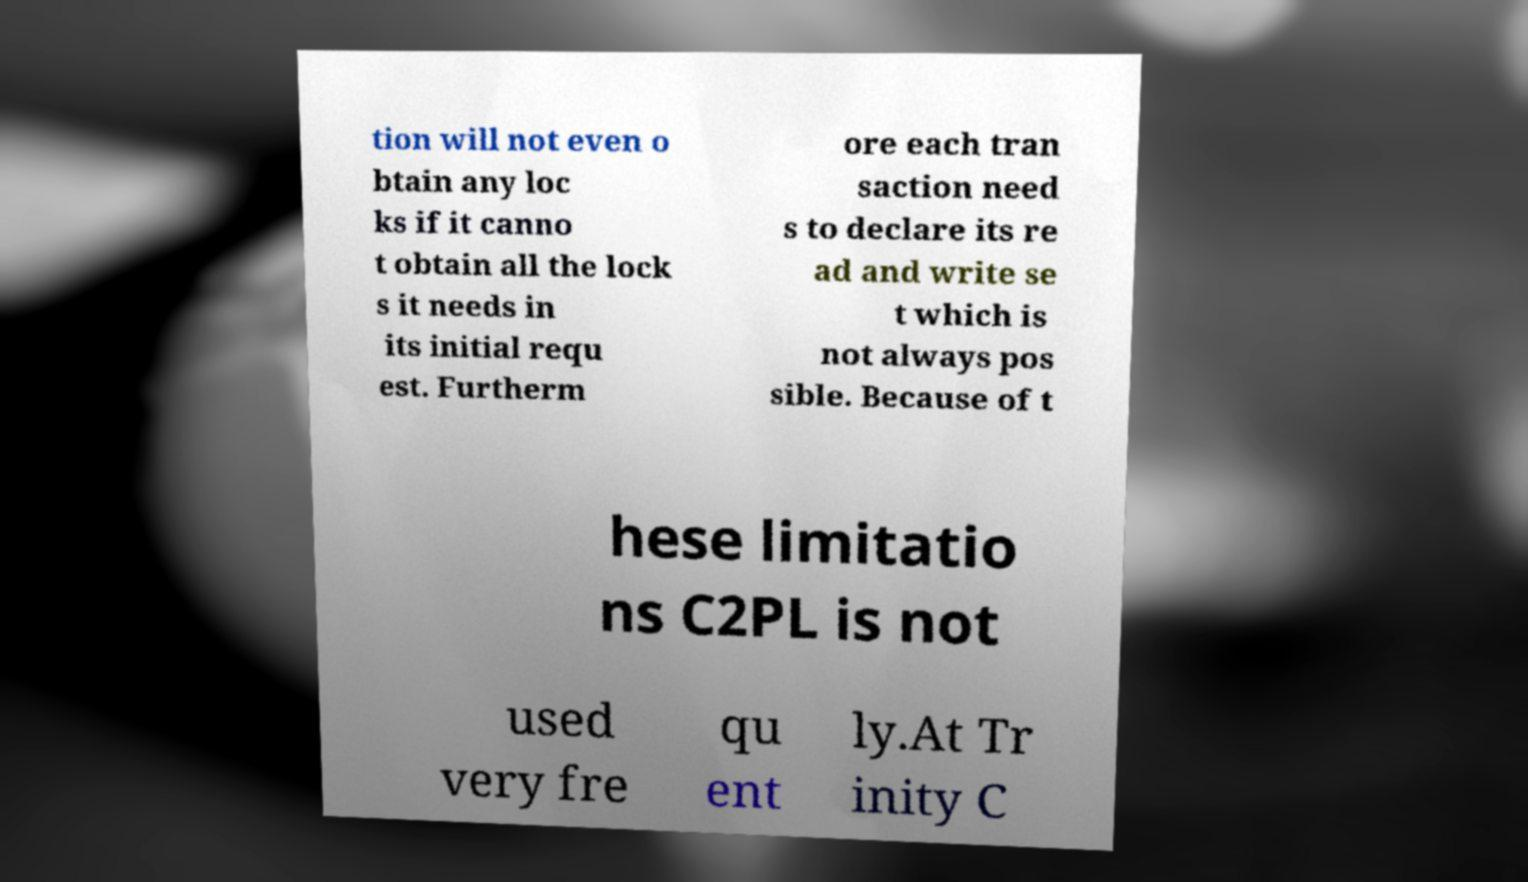Could you assist in decoding the text presented in this image and type it out clearly? tion will not even o btain any loc ks if it canno t obtain all the lock s it needs in its initial requ est. Furtherm ore each tran saction need s to declare its re ad and write se t which is not always pos sible. Because of t hese limitatio ns C2PL is not used very fre qu ent ly.At Tr inity C 